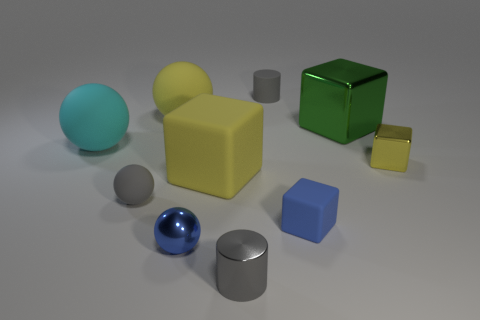There is a shiny thing that is on the right side of the tiny blue metal object and on the left side of the green metallic block; what is its color? gray 